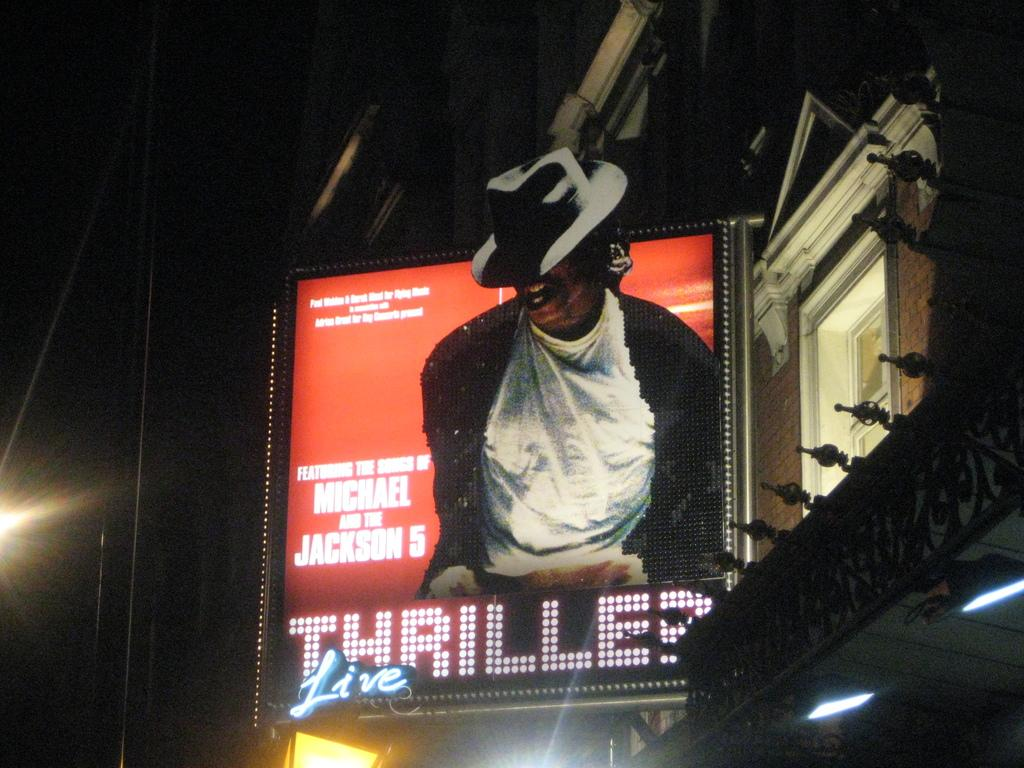What is on the board that is attached to the building in the image? There is text and an image of a person on the board in the image. Where is the board located in relation to the building? The board is attached to the building. What else can be seen on the building besides the board? There are lights visible on the building. How does the notebook help the person on the board to fly in the image? There is no notebook or person flying in the image; it only features a board with text and an image of a person. 